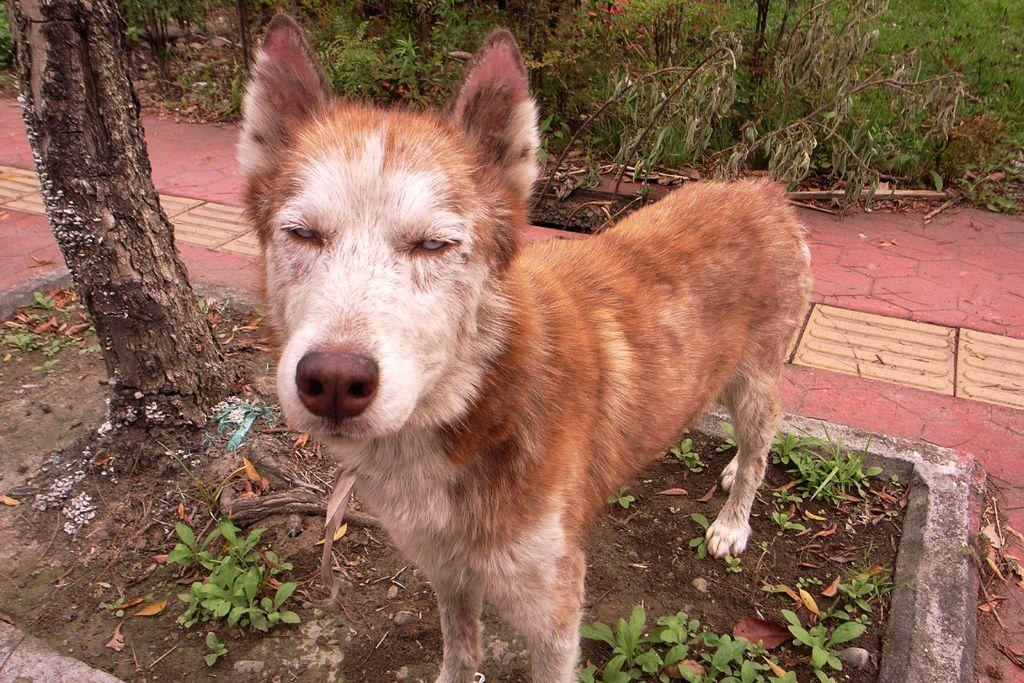What type of animal is in the image? There is a dog in the image. Can you describe the dog's appearance? The dog has cream and brown colors. What can be seen in the background of the image? There are plants and flowers in the background of the image. What color are the plants in the image? The plants are green. What color are the flowers in the image? The flowers are red. What type of pen is the dog holding in the image? There is no pen present in the image; it features a dog with cream and brown colors and a background of green plants and red flowers. What kind of machine is depicted in the image? There is no machine present in the image; it features a dog and a background of plants and flowers. 